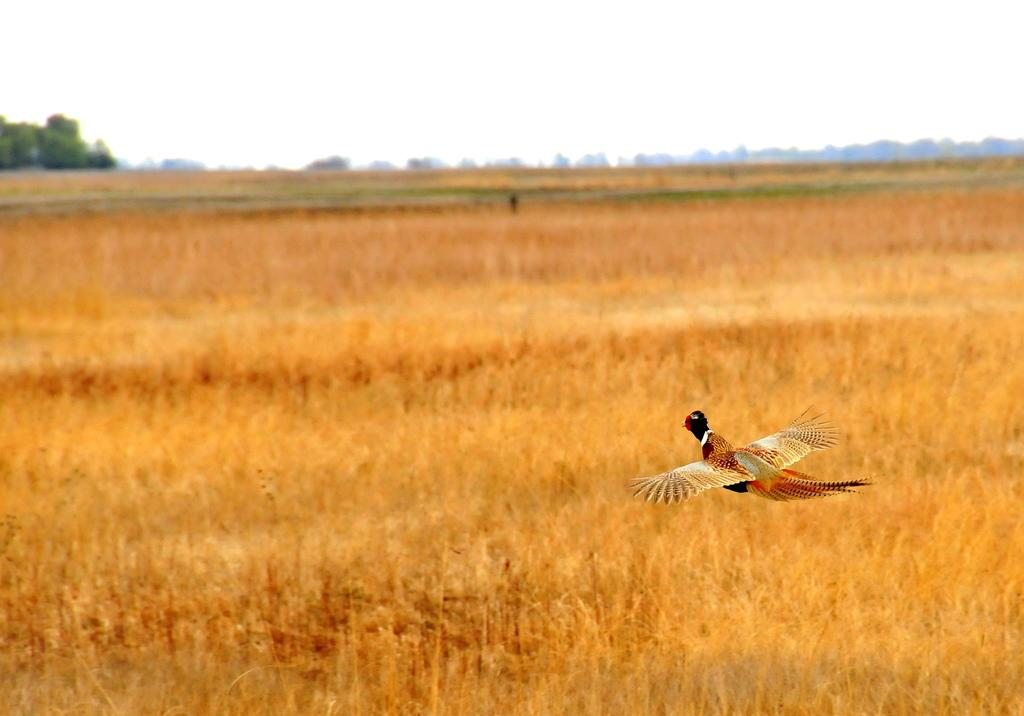What is the main subject of the image? There is a bird flying in the air. What type of terrain is visible in the image? There is grass visible in the image. What can be seen in the background of the image? There are trees and the sky visible in the background of the image. What type of needle is the bird using to sew leaves together in the image? There is no needle or sewing activity present in the image; it features a bird flying in the air. Can you tell me how many goats are grazing on the grass in the image? There are no goats present in the image; it only features a bird flying in the air and grass. 